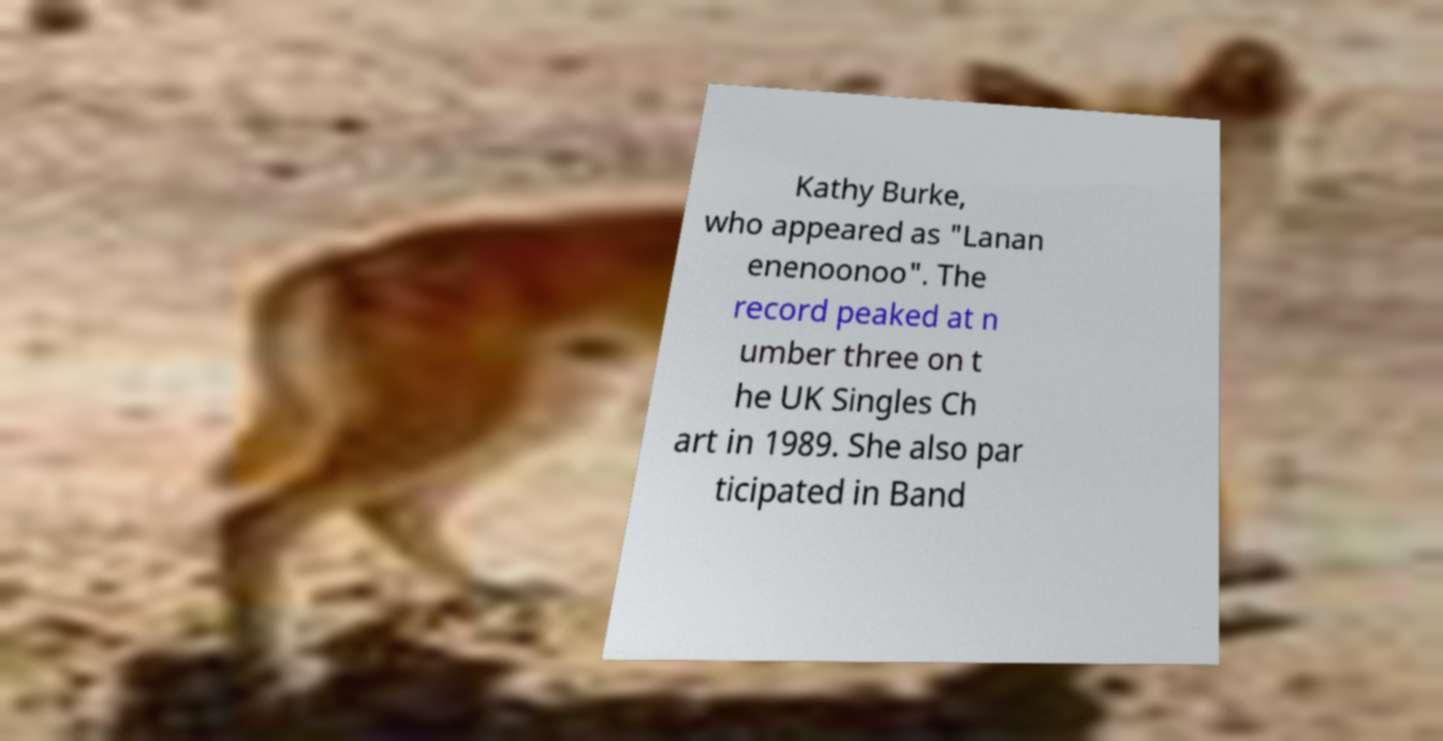Could you assist in decoding the text presented in this image and type it out clearly? Kathy Burke, who appeared as "Lanan enenoonoo". The record peaked at n umber three on t he UK Singles Ch art in 1989. She also par ticipated in Band 